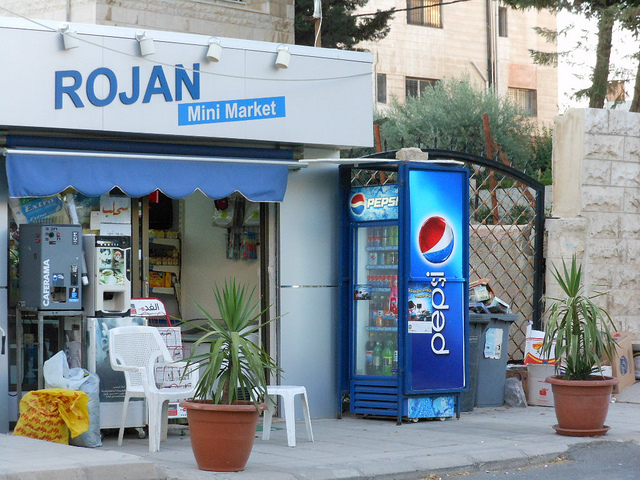What time of day does it appear to be, and what are the clues that suggest this? It seems to be daytime – possibly morning or late afternoon, as evidenced by the shadows cast on the ground, suggesting the presence of sunlight, but not directly overhead. 